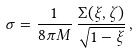<formula> <loc_0><loc_0><loc_500><loc_500>\sigma = \frac { 1 } { 8 \pi M } \, \frac { \Sigma ( \xi , \zeta ) } { \sqrt { 1 - \xi } } \, ,</formula> 